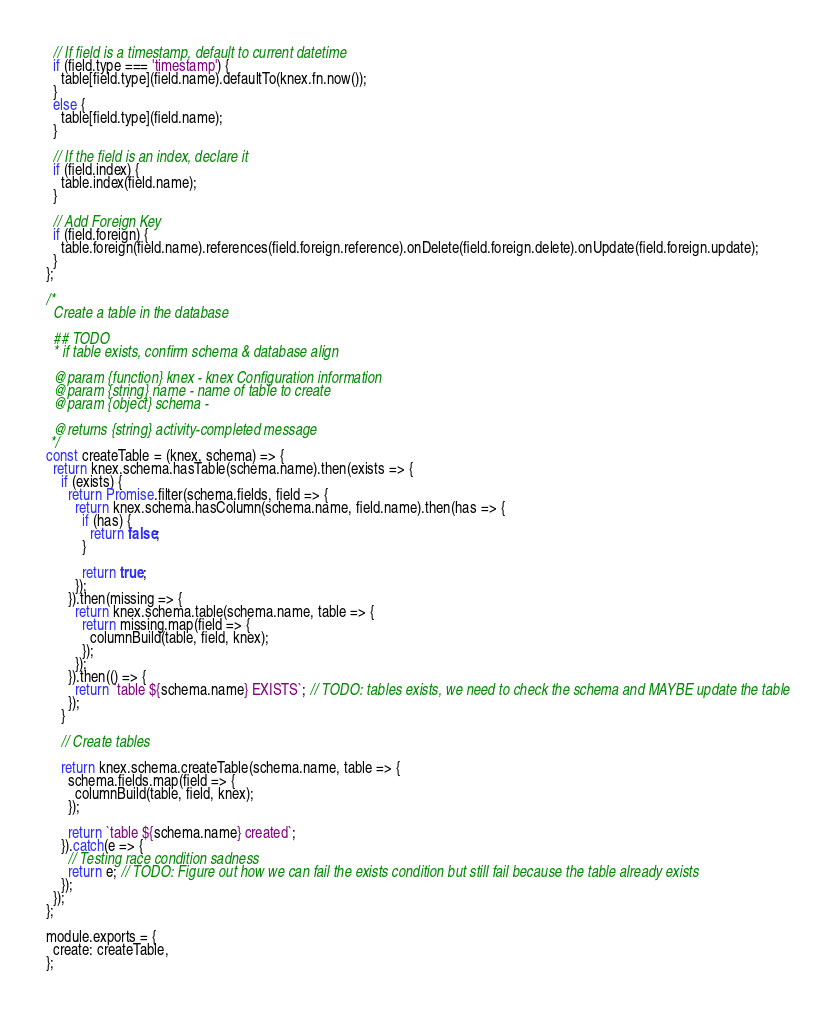<code> <loc_0><loc_0><loc_500><loc_500><_JavaScript_>  // If field is a timestamp, default to current datetime
  if (field.type === 'timestamp') {
    table[field.type](field.name).defaultTo(knex.fn.now());
  }
  else {
    table[field.type](field.name);
  }

  // If the field is an index, declare it
  if (field.index) {
    table.index(field.name);
  }

  // Add Foreign Key
  if (field.foreign) {
    table.foreign(field.name).references(field.foreign.reference).onDelete(field.foreign.delete).onUpdate(field.foreign.update);
  }
};

/*
  Create a table in the database

  ## TODO
  * if table exists, confirm schema & database align

  @param {function} knex - knex Configuration information
  @param {string} name - name of table to create
  @param {object} schema -

  @returns {string} activity-completed message
 */
const createTable = (knex, schema) => {
  return knex.schema.hasTable(schema.name).then(exists => {
    if (exists) {
      return Promise.filter(schema.fields, field => {
        return knex.schema.hasColumn(schema.name, field.name).then(has => {
          if (has) {
            return false;
          }

          return true;
        });
      }).then(missing => {
        return knex.schema.table(schema.name, table => {
          return missing.map(field => {
            columnBuild(table, field, knex);
          });
        });
      }).then(() => {
        return `table ${schema.name} EXISTS`; // TODO: tables exists, we need to check the schema and MAYBE update the table
      });
    }

    // Create tables

    return knex.schema.createTable(schema.name, table => {
      schema.fields.map(field => {
        columnBuild(table, field, knex);
      });

      return `table ${schema.name} created`;
    }).catch(e => {
      // Testing race condition sadness
      return e; // TODO: Figure out how we can fail the exists condition but still fail because the table already exists
    });
  });
};

module.exports = {
  create: createTable,
};
</code> 